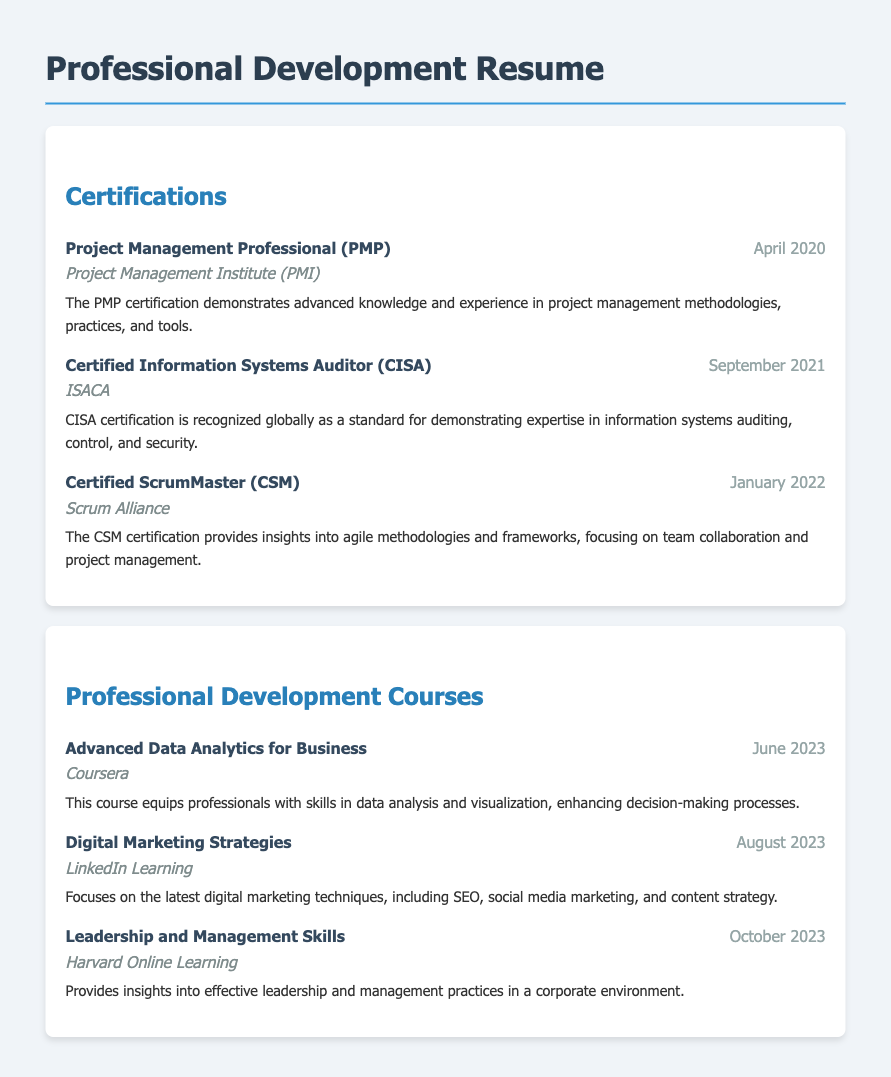What is the certification earned in April 2020? The certification earned in April 2020 is listed as Project Management Professional (PMP).
Answer: Project Management Professional (PMP) Who awarded the CISA certification? The organization that awarded the CISA certification is noted in the document as ISACA.
Answer: ISACA When was the Certified ScrumMaster (CSM) received? The date the Certified ScrumMaster (CSM) was received is mentioned in the document as January 2022.
Answer: January 2022 What is the title of the course completed in June 2023? The title of the course completed in June 2023 is specified as Advanced Data Analytics for Business.
Answer: Advanced Data Analytics for Business Which organization provided the Leadership and Management Skills course? The organization that provided the Leadership and Management Skills course is Harvard Online Learning.
Answer: Harvard Online Learning Which certification focuses on agile methodologies? The certification that focuses on agile methodologies is the Certified ScrumMaster (CSM).
Answer: Certified ScrumMaster (CSM) What is the main topic of the Digital Marketing Strategies course? The main topic of the Digital Marketing Strategies course is digital marketing techniques including SEO, social media marketing, and content strategy.
Answer: digital marketing techniques How many certifications are listed in the document? The document lists three certifications, which can be counted by reviewing the certifications section.
Answer: three When was the last professional development course completed? The last professional development course was completed in the month of October 2023, which is the most current date given.
Answer: October 2023 